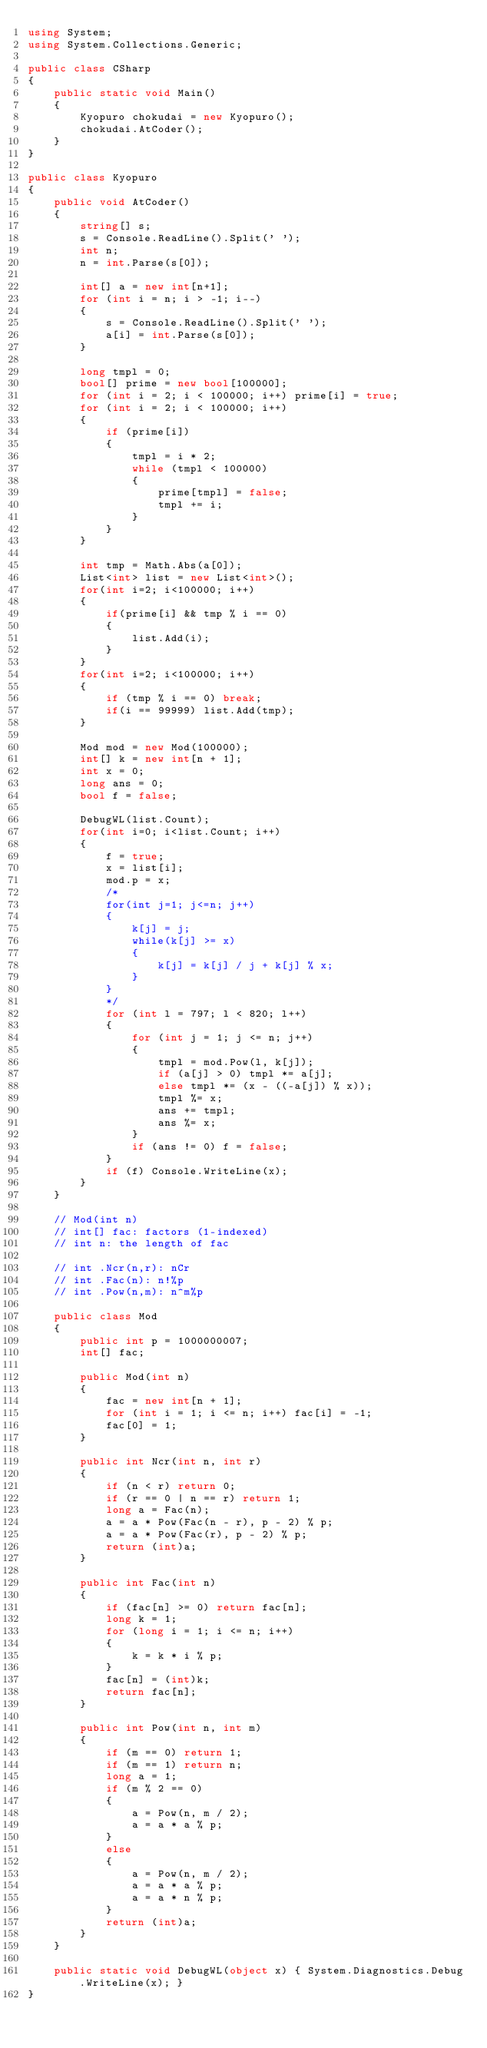Convert code to text. <code><loc_0><loc_0><loc_500><loc_500><_C#_>using System;
using System.Collections.Generic;

public class CSharp
{
    public static void Main()
    {
        Kyopuro chokudai = new Kyopuro();
        chokudai.AtCoder();
    }
}

public class Kyopuro
{
    public void AtCoder()
    {
        string[] s;
        s = Console.ReadLine().Split(' ');
        int n;
        n = int.Parse(s[0]);

        int[] a = new int[n+1];
        for (int i = n; i > -1; i--)
        {
            s = Console.ReadLine().Split(' ');
            a[i] = int.Parse(s[0]);
        }

        long tmpl = 0;
        bool[] prime = new bool[100000];
        for (int i = 2; i < 100000; i++) prime[i] = true;
        for (int i = 2; i < 100000; i++)
        {
            if (prime[i])
            {
                tmpl = i * 2;
                while (tmpl < 100000)
                {
                    prime[tmpl] = false;
                    tmpl += i;
                }
            }
        }

        int tmp = Math.Abs(a[0]);
        List<int> list = new List<int>();
        for(int i=2; i<100000; i++)
        {
            if(prime[i] && tmp % i == 0)
            {
                list.Add(i);
            }
        }
        for(int i=2; i<100000; i++)
        {
            if (tmp % i == 0) break;
            if(i == 99999) list.Add(tmp);
        }

        Mod mod = new Mod(100000);
        int[] k = new int[n + 1];
        int x = 0;
        long ans = 0;
        bool f = false;

        DebugWL(list.Count);
        for(int i=0; i<list.Count; i++)
        {
            f = true;
            x = list[i];
            mod.p = x;
            /*
            for(int j=1; j<=n; j++)
            {
                k[j] = j;
                while(k[j] >= x)
                {
                    k[j] = k[j] / j + k[j] % x;
                }
            }
            */
            for (int l = 797; l < 820; l++)
            {
                for (int j = 1; j <= n; j++)
                {
                    tmpl = mod.Pow(l, k[j]);
                    if (a[j] > 0) tmpl *= a[j];
                    else tmpl *= (x - ((-a[j]) % x));
                    tmpl %= x;
                    ans += tmpl;
                    ans %= x;                                
                }
                if (ans != 0) f = false;
            }
            if (f) Console.WriteLine(x);
        }
    }

    // Mod(int n)
    // int[] fac: factors (1-indexed)
    // int n: the length of fac

    // int .Ncr(n,r): nCr
    // int .Fac(n): n!%p
    // int .Pow(n,m): n^m%p

    public class Mod
    {
        public int p = 1000000007;
        int[] fac;

        public Mod(int n)
        {
            fac = new int[n + 1];
            for (int i = 1; i <= n; i++) fac[i] = -1;
            fac[0] = 1;
        }

        public int Ncr(int n, int r)
        {
            if (n < r) return 0;
            if (r == 0 | n == r) return 1;
            long a = Fac(n);
            a = a * Pow(Fac(n - r), p - 2) % p;
            a = a * Pow(Fac(r), p - 2) % p;
            return (int)a;
        }

        public int Fac(int n)
        {
            if (fac[n] >= 0) return fac[n];
            long k = 1;
            for (long i = 1; i <= n; i++)
            {
                k = k * i % p;
            }
            fac[n] = (int)k;
            return fac[n];
        }

        public int Pow(int n, int m)
        {
            if (m == 0) return 1;
            if (m == 1) return n;
            long a = 1;
            if (m % 2 == 0)
            {
                a = Pow(n, m / 2);
                a = a * a % p;
            }
            else
            {
                a = Pow(n, m / 2);
                a = a * a % p;
                a = a * n % p;
            }
            return (int)a;
        }
    }

    public static void DebugWL(object x) { System.Diagnostics.Debug.WriteLine(x); }
}
</code> 